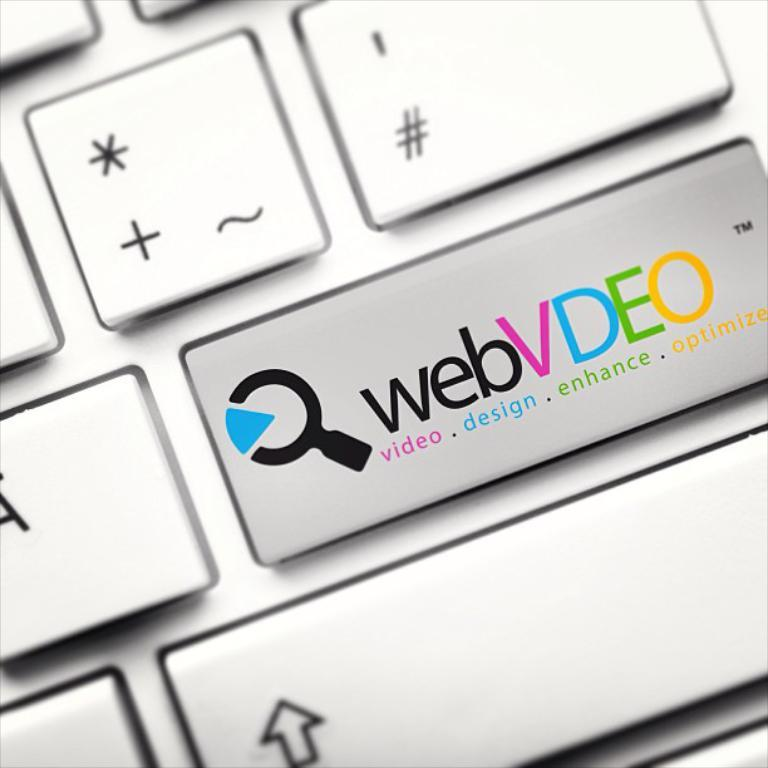<image>
Summarize the visual content of the image. a closeup shot of a keyboard with the logo wedVDEO for a company that does video, design, enhance and optimize 